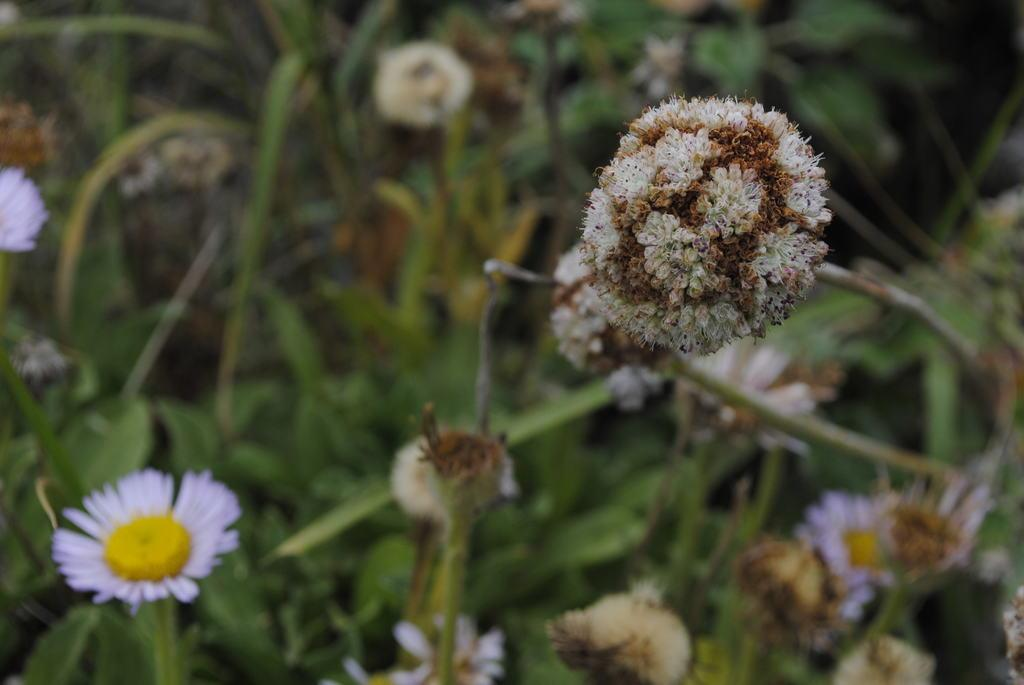What type of flora can be seen in the image? There are flowers in the image. Can you describe the colors of some of the flowers? Some flowers are white and yellow, while others are white and brown. What can be seen in the background of the image? In the background, there are plants and flowers visible. How does the crowd interact with the flowers in the image? There is no crowd present in the image; it only features flowers, plants, and their colors. 